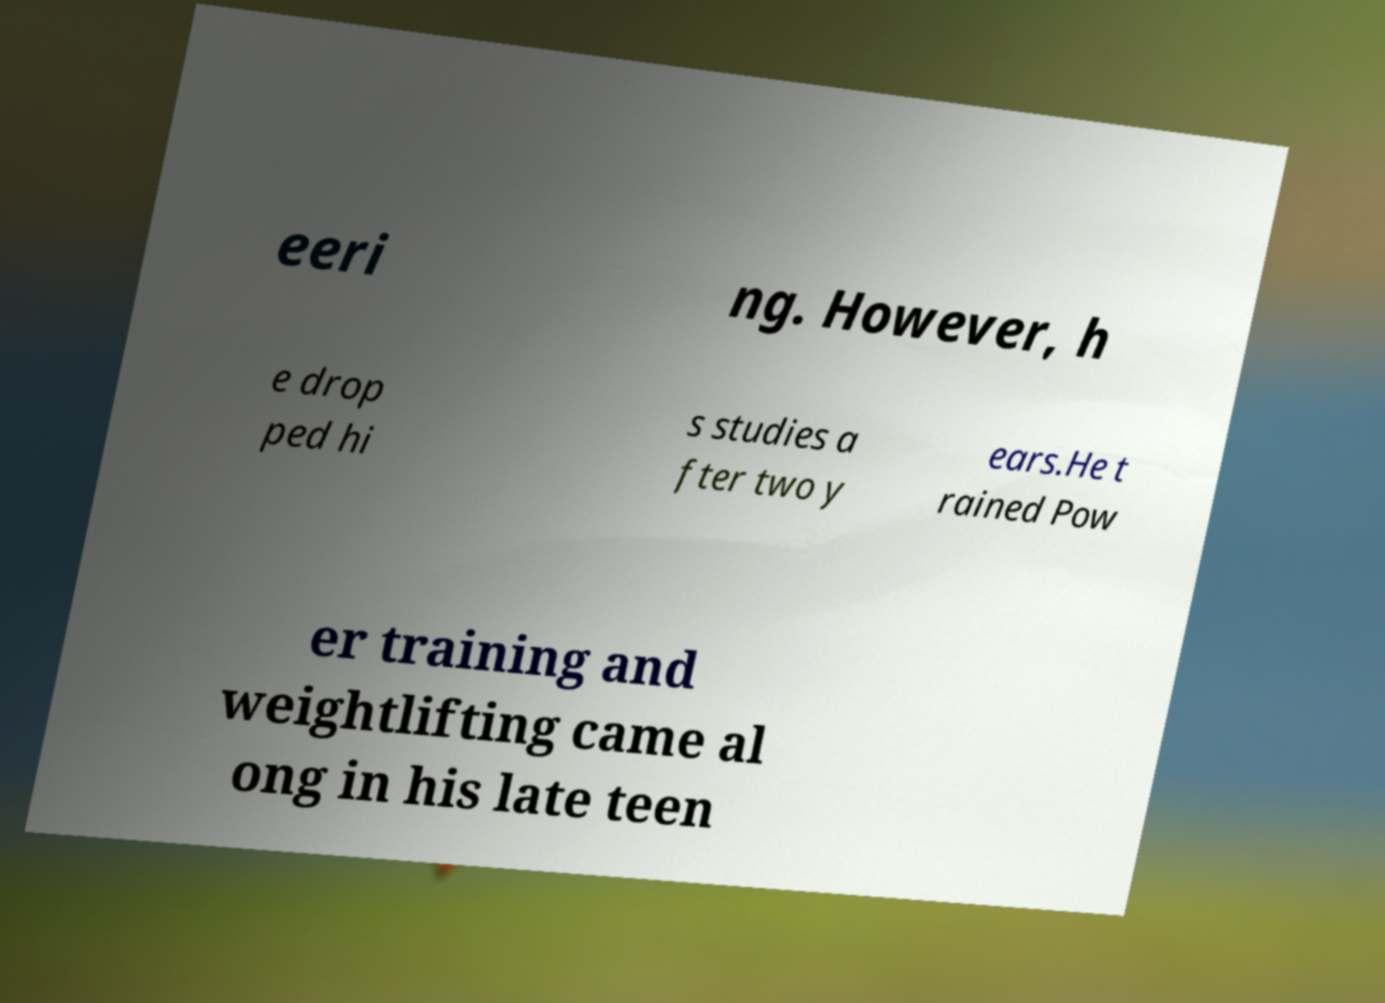Please read and relay the text visible in this image. What does it say? eeri ng. However, h e drop ped hi s studies a fter two y ears.He t rained Pow er training and weightlifting came al ong in his late teen 